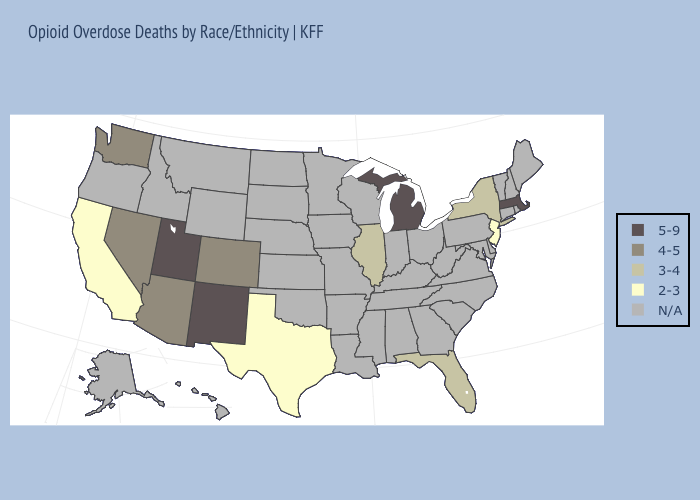Among the states that border Pennsylvania , which have the highest value?
Quick response, please. New York. What is the lowest value in the Northeast?
Be succinct. 2-3. Name the states that have a value in the range 4-5?
Concise answer only. Arizona, Colorado, Nevada, Washington. How many symbols are there in the legend?
Be succinct. 5. Which states have the lowest value in the USA?
Give a very brief answer. California, New Jersey, Texas. Does the first symbol in the legend represent the smallest category?
Quick response, please. No. Name the states that have a value in the range 5-9?
Answer briefly. Massachusetts, Michigan, New Mexico, Utah. What is the lowest value in states that border New Hampshire?
Be succinct. 5-9. What is the value of Oklahoma?
Be succinct. N/A. Among the states that border Kansas , which have the highest value?
Answer briefly. Colorado. Which states have the lowest value in the USA?
Give a very brief answer. California, New Jersey, Texas. 